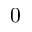<formula> <loc_0><loc_0><loc_500><loc_500>0</formula> 